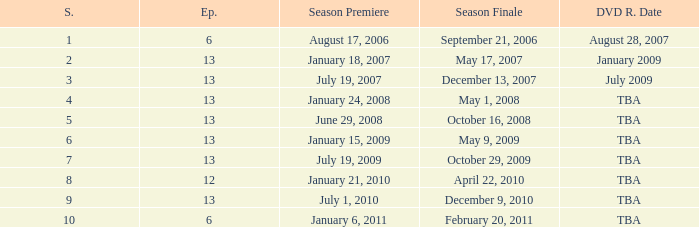Which season had fewer than 13 episodes and aired its season finale on February 20, 2011? 1.0. Would you mind parsing the complete table? {'header': ['S.', 'Ep.', 'Season Premiere', 'Season Finale', 'DVD R. Date'], 'rows': [['1', '6', 'August 17, 2006', 'September 21, 2006', 'August 28, 2007'], ['2', '13', 'January 18, 2007', 'May 17, 2007', 'January 2009'], ['3', '13', 'July 19, 2007', 'December 13, 2007', 'July 2009'], ['4', '13', 'January 24, 2008', 'May 1, 2008', 'TBA'], ['5', '13', 'June 29, 2008', 'October 16, 2008', 'TBA'], ['6', '13', 'January 15, 2009', 'May 9, 2009', 'TBA'], ['7', '13', 'July 19, 2009', 'October 29, 2009', 'TBA'], ['8', '12', 'January 21, 2010', 'April 22, 2010', 'TBA'], ['9', '13', 'July 1, 2010', 'December 9, 2010', 'TBA'], ['10', '6', 'January 6, 2011', 'February 20, 2011', 'TBA']]} 